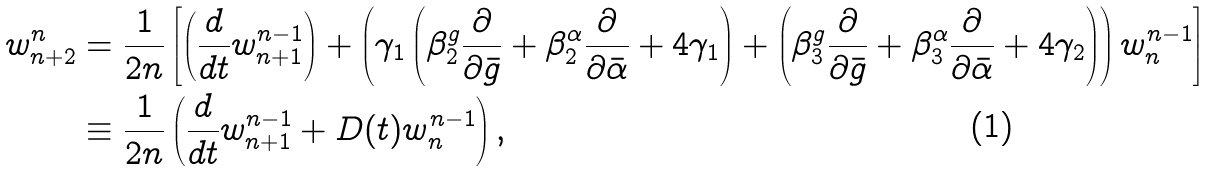<formula> <loc_0><loc_0><loc_500><loc_500>w ^ { n } _ { n + 2 } & = \frac { 1 } { 2 n } \left [ \left ( \frac { d } { d t } w ^ { n - 1 } _ { n + 1 } \right ) + \left ( \gamma _ { 1 } \left ( \beta ^ { g } _ { 2 } \frac { \partial } { \partial \bar { g } } + \beta ^ { \alpha } _ { 2 } \frac { \partial } { \partial \bar { \alpha } } + 4 \gamma _ { 1 } \right ) + \left ( \beta ^ { g } _ { 3 } \frac { \partial } { \partial \bar { g } } + \beta ^ { \alpha } _ { 3 } \frac { \partial } { \partial \bar { \alpha } } + 4 \gamma _ { 2 } \right ) \right ) w ^ { n - 1 } _ { n } \right ] \\ & \equiv \frac { 1 } { 2 n } \left ( \frac { d } { d t } w ^ { n - 1 } _ { n + 1 } + D ( t ) w ^ { n - 1 } _ { n } \right ) ,</formula> 